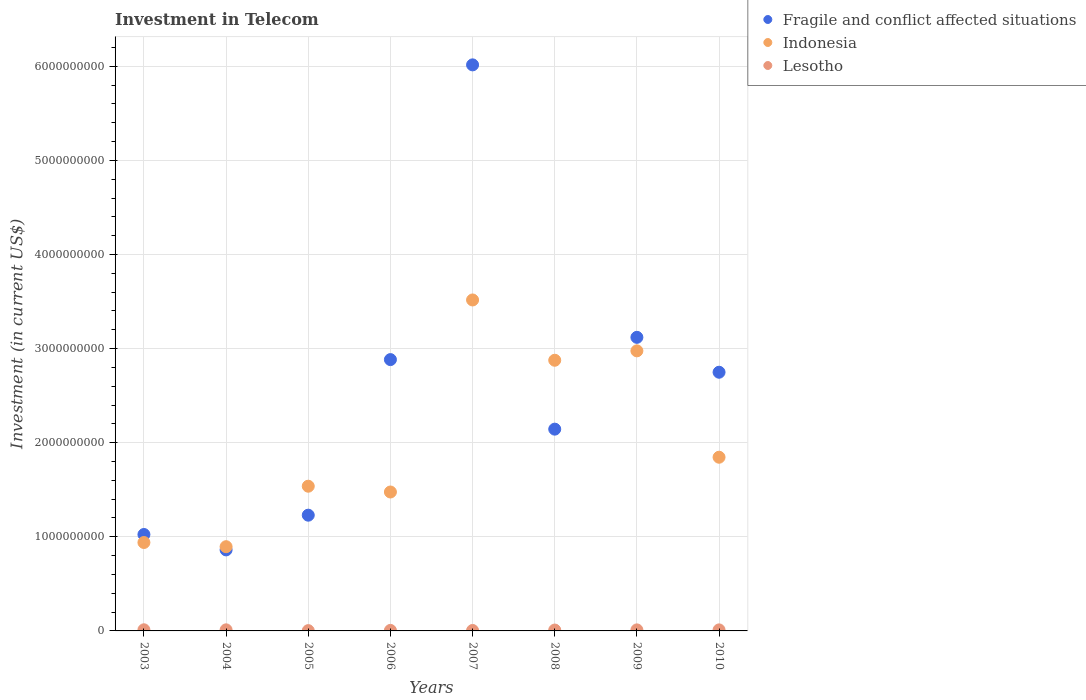What is the amount invested in telecom in Indonesia in 2008?
Provide a short and direct response. 2.88e+09. Across all years, what is the minimum amount invested in telecom in Fragile and conflict affected situations?
Provide a short and direct response. 8.61e+08. In which year was the amount invested in telecom in Indonesia maximum?
Keep it short and to the point. 2007. What is the total amount invested in telecom in Fragile and conflict affected situations in the graph?
Your answer should be very brief. 2.00e+1. What is the difference between the amount invested in telecom in Fragile and conflict affected situations in 2004 and that in 2005?
Make the answer very short. -3.69e+08. What is the difference between the amount invested in telecom in Lesotho in 2009 and the amount invested in telecom in Fragile and conflict affected situations in 2010?
Offer a terse response. -2.74e+09. What is the average amount invested in telecom in Lesotho per year?
Your response must be concise. 8.52e+06. In the year 2005, what is the difference between the amount invested in telecom in Lesotho and amount invested in telecom in Indonesia?
Make the answer very short. -1.53e+09. In how many years, is the amount invested in telecom in Indonesia greater than 5400000000 US$?
Keep it short and to the point. 0. What is the ratio of the amount invested in telecom in Fragile and conflict affected situations in 2003 to that in 2008?
Your answer should be very brief. 0.48. Is the difference between the amount invested in telecom in Lesotho in 2006 and 2010 greater than the difference between the amount invested in telecom in Indonesia in 2006 and 2010?
Ensure brevity in your answer.  Yes. What is the difference between the highest and the lowest amount invested in telecom in Indonesia?
Keep it short and to the point. 2.62e+09. In how many years, is the amount invested in telecom in Lesotho greater than the average amount invested in telecom in Lesotho taken over all years?
Offer a very short reply. 5. Is the amount invested in telecom in Lesotho strictly greater than the amount invested in telecom in Fragile and conflict affected situations over the years?
Make the answer very short. No. How many dotlines are there?
Keep it short and to the point. 3. What is the difference between two consecutive major ticks on the Y-axis?
Your answer should be very brief. 1.00e+09. Are the values on the major ticks of Y-axis written in scientific E-notation?
Offer a terse response. No. Does the graph contain any zero values?
Keep it short and to the point. No. Does the graph contain grids?
Provide a short and direct response. Yes. Where does the legend appear in the graph?
Ensure brevity in your answer.  Top right. How are the legend labels stacked?
Ensure brevity in your answer.  Vertical. What is the title of the graph?
Your response must be concise. Investment in Telecom. What is the label or title of the X-axis?
Offer a terse response. Years. What is the label or title of the Y-axis?
Your answer should be very brief. Investment (in current US$). What is the Investment (in current US$) in Fragile and conflict affected situations in 2003?
Your answer should be very brief. 1.02e+09. What is the Investment (in current US$) in Indonesia in 2003?
Provide a succinct answer. 9.40e+08. What is the Investment (in current US$) in Fragile and conflict affected situations in 2004?
Provide a succinct answer. 8.61e+08. What is the Investment (in current US$) in Indonesia in 2004?
Your answer should be compact. 8.95e+08. What is the Investment (in current US$) of Lesotho in 2004?
Make the answer very short. 1.15e+07. What is the Investment (in current US$) in Fragile and conflict affected situations in 2005?
Offer a very short reply. 1.23e+09. What is the Investment (in current US$) of Indonesia in 2005?
Offer a terse response. 1.54e+09. What is the Investment (in current US$) in Lesotho in 2005?
Offer a very short reply. 3.00e+06. What is the Investment (in current US$) of Fragile and conflict affected situations in 2006?
Provide a succinct answer. 2.88e+09. What is the Investment (in current US$) of Indonesia in 2006?
Your answer should be compact. 1.48e+09. What is the Investment (in current US$) of Lesotho in 2006?
Provide a succinct answer. 5.53e+06. What is the Investment (in current US$) in Fragile and conflict affected situations in 2007?
Your answer should be compact. 6.01e+09. What is the Investment (in current US$) of Indonesia in 2007?
Your answer should be compact. 3.52e+09. What is the Investment (in current US$) in Lesotho in 2007?
Your answer should be very brief. 4.80e+06. What is the Investment (in current US$) in Fragile and conflict affected situations in 2008?
Provide a short and direct response. 2.14e+09. What is the Investment (in current US$) of Indonesia in 2008?
Keep it short and to the point. 2.88e+09. What is the Investment (in current US$) of Lesotho in 2008?
Provide a short and direct response. 9.30e+06. What is the Investment (in current US$) of Fragile and conflict affected situations in 2009?
Give a very brief answer. 3.12e+09. What is the Investment (in current US$) of Indonesia in 2009?
Provide a short and direct response. 2.98e+09. What is the Investment (in current US$) of Lesotho in 2009?
Provide a short and direct response. 1.10e+07. What is the Investment (in current US$) of Fragile and conflict affected situations in 2010?
Offer a very short reply. 2.75e+09. What is the Investment (in current US$) of Indonesia in 2010?
Your answer should be very brief. 1.85e+09. What is the Investment (in current US$) of Lesotho in 2010?
Ensure brevity in your answer.  1.10e+07. Across all years, what is the maximum Investment (in current US$) in Fragile and conflict affected situations?
Provide a succinct answer. 6.01e+09. Across all years, what is the maximum Investment (in current US$) in Indonesia?
Your answer should be very brief. 3.52e+09. Across all years, what is the minimum Investment (in current US$) of Fragile and conflict affected situations?
Provide a succinct answer. 8.61e+08. Across all years, what is the minimum Investment (in current US$) in Indonesia?
Offer a terse response. 8.95e+08. What is the total Investment (in current US$) in Fragile and conflict affected situations in the graph?
Your answer should be very brief. 2.00e+1. What is the total Investment (in current US$) in Indonesia in the graph?
Keep it short and to the point. 1.61e+1. What is the total Investment (in current US$) of Lesotho in the graph?
Keep it short and to the point. 6.81e+07. What is the difference between the Investment (in current US$) of Fragile and conflict affected situations in 2003 and that in 2004?
Make the answer very short. 1.64e+08. What is the difference between the Investment (in current US$) in Indonesia in 2003 and that in 2004?
Make the answer very short. 4.45e+07. What is the difference between the Investment (in current US$) in Fragile and conflict affected situations in 2003 and that in 2005?
Your response must be concise. -2.05e+08. What is the difference between the Investment (in current US$) in Indonesia in 2003 and that in 2005?
Your response must be concise. -5.98e+08. What is the difference between the Investment (in current US$) of Lesotho in 2003 and that in 2005?
Keep it short and to the point. 9.00e+06. What is the difference between the Investment (in current US$) in Fragile and conflict affected situations in 2003 and that in 2006?
Provide a succinct answer. -1.86e+09. What is the difference between the Investment (in current US$) in Indonesia in 2003 and that in 2006?
Your response must be concise. -5.37e+08. What is the difference between the Investment (in current US$) of Lesotho in 2003 and that in 2006?
Your response must be concise. 6.47e+06. What is the difference between the Investment (in current US$) in Fragile and conflict affected situations in 2003 and that in 2007?
Give a very brief answer. -4.99e+09. What is the difference between the Investment (in current US$) in Indonesia in 2003 and that in 2007?
Your answer should be compact. -2.58e+09. What is the difference between the Investment (in current US$) in Lesotho in 2003 and that in 2007?
Offer a terse response. 7.20e+06. What is the difference between the Investment (in current US$) of Fragile and conflict affected situations in 2003 and that in 2008?
Ensure brevity in your answer.  -1.12e+09. What is the difference between the Investment (in current US$) in Indonesia in 2003 and that in 2008?
Your answer should be very brief. -1.94e+09. What is the difference between the Investment (in current US$) in Lesotho in 2003 and that in 2008?
Provide a short and direct response. 2.70e+06. What is the difference between the Investment (in current US$) of Fragile and conflict affected situations in 2003 and that in 2009?
Your response must be concise. -2.09e+09. What is the difference between the Investment (in current US$) of Indonesia in 2003 and that in 2009?
Offer a very short reply. -2.04e+09. What is the difference between the Investment (in current US$) of Lesotho in 2003 and that in 2009?
Your response must be concise. 1.00e+06. What is the difference between the Investment (in current US$) of Fragile and conflict affected situations in 2003 and that in 2010?
Your answer should be very brief. -1.72e+09. What is the difference between the Investment (in current US$) of Indonesia in 2003 and that in 2010?
Make the answer very short. -9.06e+08. What is the difference between the Investment (in current US$) in Lesotho in 2003 and that in 2010?
Offer a very short reply. 1.00e+06. What is the difference between the Investment (in current US$) in Fragile and conflict affected situations in 2004 and that in 2005?
Provide a succinct answer. -3.69e+08. What is the difference between the Investment (in current US$) of Indonesia in 2004 and that in 2005?
Make the answer very short. -6.43e+08. What is the difference between the Investment (in current US$) in Lesotho in 2004 and that in 2005?
Provide a succinct answer. 8.50e+06. What is the difference between the Investment (in current US$) of Fragile and conflict affected situations in 2004 and that in 2006?
Provide a short and direct response. -2.02e+09. What is the difference between the Investment (in current US$) in Indonesia in 2004 and that in 2006?
Provide a succinct answer. -5.81e+08. What is the difference between the Investment (in current US$) in Lesotho in 2004 and that in 2006?
Ensure brevity in your answer.  5.97e+06. What is the difference between the Investment (in current US$) of Fragile and conflict affected situations in 2004 and that in 2007?
Provide a short and direct response. -5.15e+09. What is the difference between the Investment (in current US$) of Indonesia in 2004 and that in 2007?
Your response must be concise. -2.62e+09. What is the difference between the Investment (in current US$) of Lesotho in 2004 and that in 2007?
Keep it short and to the point. 6.70e+06. What is the difference between the Investment (in current US$) of Fragile and conflict affected situations in 2004 and that in 2008?
Your answer should be compact. -1.28e+09. What is the difference between the Investment (in current US$) of Indonesia in 2004 and that in 2008?
Your response must be concise. -1.98e+09. What is the difference between the Investment (in current US$) in Lesotho in 2004 and that in 2008?
Keep it short and to the point. 2.20e+06. What is the difference between the Investment (in current US$) in Fragile and conflict affected situations in 2004 and that in 2009?
Ensure brevity in your answer.  -2.26e+09. What is the difference between the Investment (in current US$) in Indonesia in 2004 and that in 2009?
Keep it short and to the point. -2.08e+09. What is the difference between the Investment (in current US$) in Lesotho in 2004 and that in 2009?
Give a very brief answer. 5.00e+05. What is the difference between the Investment (in current US$) of Fragile and conflict affected situations in 2004 and that in 2010?
Provide a succinct answer. -1.89e+09. What is the difference between the Investment (in current US$) of Indonesia in 2004 and that in 2010?
Offer a terse response. -9.51e+08. What is the difference between the Investment (in current US$) of Fragile and conflict affected situations in 2005 and that in 2006?
Offer a very short reply. -1.65e+09. What is the difference between the Investment (in current US$) of Indonesia in 2005 and that in 2006?
Keep it short and to the point. 6.15e+07. What is the difference between the Investment (in current US$) in Lesotho in 2005 and that in 2006?
Your response must be concise. -2.53e+06. What is the difference between the Investment (in current US$) in Fragile and conflict affected situations in 2005 and that in 2007?
Your answer should be compact. -4.78e+09. What is the difference between the Investment (in current US$) in Indonesia in 2005 and that in 2007?
Your answer should be compact. -1.98e+09. What is the difference between the Investment (in current US$) of Lesotho in 2005 and that in 2007?
Provide a short and direct response. -1.80e+06. What is the difference between the Investment (in current US$) in Fragile and conflict affected situations in 2005 and that in 2008?
Make the answer very short. -9.14e+08. What is the difference between the Investment (in current US$) of Indonesia in 2005 and that in 2008?
Provide a short and direct response. -1.34e+09. What is the difference between the Investment (in current US$) of Lesotho in 2005 and that in 2008?
Give a very brief answer. -6.30e+06. What is the difference between the Investment (in current US$) of Fragile and conflict affected situations in 2005 and that in 2009?
Provide a short and direct response. -1.89e+09. What is the difference between the Investment (in current US$) in Indonesia in 2005 and that in 2009?
Offer a very short reply. -1.44e+09. What is the difference between the Investment (in current US$) in Lesotho in 2005 and that in 2009?
Offer a terse response. -8.00e+06. What is the difference between the Investment (in current US$) of Fragile and conflict affected situations in 2005 and that in 2010?
Provide a succinct answer. -1.52e+09. What is the difference between the Investment (in current US$) in Indonesia in 2005 and that in 2010?
Ensure brevity in your answer.  -3.08e+08. What is the difference between the Investment (in current US$) in Lesotho in 2005 and that in 2010?
Offer a terse response. -8.00e+06. What is the difference between the Investment (in current US$) in Fragile and conflict affected situations in 2006 and that in 2007?
Ensure brevity in your answer.  -3.13e+09. What is the difference between the Investment (in current US$) of Indonesia in 2006 and that in 2007?
Make the answer very short. -2.04e+09. What is the difference between the Investment (in current US$) in Lesotho in 2006 and that in 2007?
Provide a succinct answer. 7.30e+05. What is the difference between the Investment (in current US$) of Fragile and conflict affected situations in 2006 and that in 2008?
Ensure brevity in your answer.  7.39e+08. What is the difference between the Investment (in current US$) of Indonesia in 2006 and that in 2008?
Give a very brief answer. -1.40e+09. What is the difference between the Investment (in current US$) of Lesotho in 2006 and that in 2008?
Your answer should be compact. -3.77e+06. What is the difference between the Investment (in current US$) of Fragile and conflict affected situations in 2006 and that in 2009?
Provide a short and direct response. -2.37e+08. What is the difference between the Investment (in current US$) of Indonesia in 2006 and that in 2009?
Make the answer very short. -1.50e+09. What is the difference between the Investment (in current US$) of Lesotho in 2006 and that in 2009?
Make the answer very short. -5.47e+06. What is the difference between the Investment (in current US$) of Fragile and conflict affected situations in 2006 and that in 2010?
Your response must be concise. 1.34e+08. What is the difference between the Investment (in current US$) of Indonesia in 2006 and that in 2010?
Give a very brief answer. -3.70e+08. What is the difference between the Investment (in current US$) of Lesotho in 2006 and that in 2010?
Keep it short and to the point. -5.47e+06. What is the difference between the Investment (in current US$) in Fragile and conflict affected situations in 2007 and that in 2008?
Keep it short and to the point. 3.87e+09. What is the difference between the Investment (in current US$) of Indonesia in 2007 and that in 2008?
Keep it short and to the point. 6.41e+08. What is the difference between the Investment (in current US$) of Lesotho in 2007 and that in 2008?
Offer a terse response. -4.50e+06. What is the difference between the Investment (in current US$) in Fragile and conflict affected situations in 2007 and that in 2009?
Offer a very short reply. 2.90e+09. What is the difference between the Investment (in current US$) of Indonesia in 2007 and that in 2009?
Offer a terse response. 5.41e+08. What is the difference between the Investment (in current US$) of Lesotho in 2007 and that in 2009?
Offer a terse response. -6.20e+06. What is the difference between the Investment (in current US$) of Fragile and conflict affected situations in 2007 and that in 2010?
Your answer should be compact. 3.27e+09. What is the difference between the Investment (in current US$) of Indonesia in 2007 and that in 2010?
Give a very brief answer. 1.67e+09. What is the difference between the Investment (in current US$) in Lesotho in 2007 and that in 2010?
Offer a terse response. -6.20e+06. What is the difference between the Investment (in current US$) in Fragile and conflict affected situations in 2008 and that in 2009?
Your answer should be compact. -9.76e+08. What is the difference between the Investment (in current US$) in Indonesia in 2008 and that in 2009?
Your response must be concise. -9.99e+07. What is the difference between the Investment (in current US$) in Lesotho in 2008 and that in 2009?
Provide a short and direct response. -1.70e+06. What is the difference between the Investment (in current US$) in Fragile and conflict affected situations in 2008 and that in 2010?
Keep it short and to the point. -6.05e+08. What is the difference between the Investment (in current US$) in Indonesia in 2008 and that in 2010?
Provide a succinct answer. 1.03e+09. What is the difference between the Investment (in current US$) of Lesotho in 2008 and that in 2010?
Ensure brevity in your answer.  -1.70e+06. What is the difference between the Investment (in current US$) of Fragile and conflict affected situations in 2009 and that in 2010?
Provide a short and direct response. 3.71e+08. What is the difference between the Investment (in current US$) in Indonesia in 2009 and that in 2010?
Your answer should be very brief. 1.13e+09. What is the difference between the Investment (in current US$) in Lesotho in 2009 and that in 2010?
Your response must be concise. 0. What is the difference between the Investment (in current US$) in Fragile and conflict affected situations in 2003 and the Investment (in current US$) in Indonesia in 2004?
Make the answer very short. 1.30e+08. What is the difference between the Investment (in current US$) in Fragile and conflict affected situations in 2003 and the Investment (in current US$) in Lesotho in 2004?
Offer a very short reply. 1.01e+09. What is the difference between the Investment (in current US$) of Indonesia in 2003 and the Investment (in current US$) of Lesotho in 2004?
Give a very brief answer. 9.28e+08. What is the difference between the Investment (in current US$) of Fragile and conflict affected situations in 2003 and the Investment (in current US$) of Indonesia in 2005?
Offer a terse response. -5.13e+08. What is the difference between the Investment (in current US$) of Fragile and conflict affected situations in 2003 and the Investment (in current US$) of Lesotho in 2005?
Make the answer very short. 1.02e+09. What is the difference between the Investment (in current US$) in Indonesia in 2003 and the Investment (in current US$) in Lesotho in 2005?
Offer a terse response. 9.36e+08. What is the difference between the Investment (in current US$) of Fragile and conflict affected situations in 2003 and the Investment (in current US$) of Indonesia in 2006?
Provide a succinct answer. -4.52e+08. What is the difference between the Investment (in current US$) of Fragile and conflict affected situations in 2003 and the Investment (in current US$) of Lesotho in 2006?
Your answer should be very brief. 1.02e+09. What is the difference between the Investment (in current US$) of Indonesia in 2003 and the Investment (in current US$) of Lesotho in 2006?
Offer a terse response. 9.34e+08. What is the difference between the Investment (in current US$) of Fragile and conflict affected situations in 2003 and the Investment (in current US$) of Indonesia in 2007?
Provide a short and direct response. -2.49e+09. What is the difference between the Investment (in current US$) of Fragile and conflict affected situations in 2003 and the Investment (in current US$) of Lesotho in 2007?
Keep it short and to the point. 1.02e+09. What is the difference between the Investment (in current US$) in Indonesia in 2003 and the Investment (in current US$) in Lesotho in 2007?
Make the answer very short. 9.35e+08. What is the difference between the Investment (in current US$) of Fragile and conflict affected situations in 2003 and the Investment (in current US$) of Indonesia in 2008?
Your answer should be very brief. -1.85e+09. What is the difference between the Investment (in current US$) in Fragile and conflict affected situations in 2003 and the Investment (in current US$) in Lesotho in 2008?
Offer a terse response. 1.02e+09. What is the difference between the Investment (in current US$) of Indonesia in 2003 and the Investment (in current US$) of Lesotho in 2008?
Your answer should be compact. 9.30e+08. What is the difference between the Investment (in current US$) in Fragile and conflict affected situations in 2003 and the Investment (in current US$) in Indonesia in 2009?
Your answer should be very brief. -1.95e+09. What is the difference between the Investment (in current US$) of Fragile and conflict affected situations in 2003 and the Investment (in current US$) of Lesotho in 2009?
Give a very brief answer. 1.01e+09. What is the difference between the Investment (in current US$) in Indonesia in 2003 and the Investment (in current US$) in Lesotho in 2009?
Offer a terse response. 9.28e+08. What is the difference between the Investment (in current US$) in Fragile and conflict affected situations in 2003 and the Investment (in current US$) in Indonesia in 2010?
Keep it short and to the point. -8.21e+08. What is the difference between the Investment (in current US$) of Fragile and conflict affected situations in 2003 and the Investment (in current US$) of Lesotho in 2010?
Your answer should be compact. 1.01e+09. What is the difference between the Investment (in current US$) of Indonesia in 2003 and the Investment (in current US$) of Lesotho in 2010?
Provide a succinct answer. 9.28e+08. What is the difference between the Investment (in current US$) of Fragile and conflict affected situations in 2004 and the Investment (in current US$) of Indonesia in 2005?
Give a very brief answer. -6.77e+08. What is the difference between the Investment (in current US$) of Fragile and conflict affected situations in 2004 and the Investment (in current US$) of Lesotho in 2005?
Give a very brief answer. 8.58e+08. What is the difference between the Investment (in current US$) in Indonesia in 2004 and the Investment (in current US$) in Lesotho in 2005?
Your answer should be very brief. 8.92e+08. What is the difference between the Investment (in current US$) in Fragile and conflict affected situations in 2004 and the Investment (in current US$) in Indonesia in 2006?
Provide a succinct answer. -6.15e+08. What is the difference between the Investment (in current US$) of Fragile and conflict affected situations in 2004 and the Investment (in current US$) of Lesotho in 2006?
Keep it short and to the point. 8.55e+08. What is the difference between the Investment (in current US$) in Indonesia in 2004 and the Investment (in current US$) in Lesotho in 2006?
Provide a succinct answer. 8.89e+08. What is the difference between the Investment (in current US$) of Fragile and conflict affected situations in 2004 and the Investment (in current US$) of Indonesia in 2007?
Give a very brief answer. -2.66e+09. What is the difference between the Investment (in current US$) in Fragile and conflict affected situations in 2004 and the Investment (in current US$) in Lesotho in 2007?
Your answer should be very brief. 8.56e+08. What is the difference between the Investment (in current US$) of Indonesia in 2004 and the Investment (in current US$) of Lesotho in 2007?
Ensure brevity in your answer.  8.90e+08. What is the difference between the Investment (in current US$) in Fragile and conflict affected situations in 2004 and the Investment (in current US$) in Indonesia in 2008?
Ensure brevity in your answer.  -2.02e+09. What is the difference between the Investment (in current US$) in Fragile and conflict affected situations in 2004 and the Investment (in current US$) in Lesotho in 2008?
Make the answer very short. 8.52e+08. What is the difference between the Investment (in current US$) of Indonesia in 2004 and the Investment (in current US$) of Lesotho in 2008?
Offer a very short reply. 8.86e+08. What is the difference between the Investment (in current US$) in Fragile and conflict affected situations in 2004 and the Investment (in current US$) in Indonesia in 2009?
Your answer should be very brief. -2.12e+09. What is the difference between the Investment (in current US$) of Fragile and conflict affected situations in 2004 and the Investment (in current US$) of Lesotho in 2009?
Your answer should be compact. 8.50e+08. What is the difference between the Investment (in current US$) of Indonesia in 2004 and the Investment (in current US$) of Lesotho in 2009?
Give a very brief answer. 8.84e+08. What is the difference between the Investment (in current US$) of Fragile and conflict affected situations in 2004 and the Investment (in current US$) of Indonesia in 2010?
Your response must be concise. -9.85e+08. What is the difference between the Investment (in current US$) in Fragile and conflict affected situations in 2004 and the Investment (in current US$) in Lesotho in 2010?
Make the answer very short. 8.50e+08. What is the difference between the Investment (in current US$) in Indonesia in 2004 and the Investment (in current US$) in Lesotho in 2010?
Provide a succinct answer. 8.84e+08. What is the difference between the Investment (in current US$) of Fragile and conflict affected situations in 2005 and the Investment (in current US$) of Indonesia in 2006?
Provide a short and direct response. -2.46e+08. What is the difference between the Investment (in current US$) of Fragile and conflict affected situations in 2005 and the Investment (in current US$) of Lesotho in 2006?
Provide a short and direct response. 1.22e+09. What is the difference between the Investment (in current US$) in Indonesia in 2005 and the Investment (in current US$) in Lesotho in 2006?
Your response must be concise. 1.53e+09. What is the difference between the Investment (in current US$) in Fragile and conflict affected situations in 2005 and the Investment (in current US$) in Indonesia in 2007?
Ensure brevity in your answer.  -2.29e+09. What is the difference between the Investment (in current US$) in Fragile and conflict affected situations in 2005 and the Investment (in current US$) in Lesotho in 2007?
Keep it short and to the point. 1.22e+09. What is the difference between the Investment (in current US$) in Indonesia in 2005 and the Investment (in current US$) in Lesotho in 2007?
Offer a terse response. 1.53e+09. What is the difference between the Investment (in current US$) of Fragile and conflict affected situations in 2005 and the Investment (in current US$) of Indonesia in 2008?
Your answer should be compact. -1.65e+09. What is the difference between the Investment (in current US$) of Fragile and conflict affected situations in 2005 and the Investment (in current US$) of Lesotho in 2008?
Your answer should be very brief. 1.22e+09. What is the difference between the Investment (in current US$) in Indonesia in 2005 and the Investment (in current US$) in Lesotho in 2008?
Give a very brief answer. 1.53e+09. What is the difference between the Investment (in current US$) in Fragile and conflict affected situations in 2005 and the Investment (in current US$) in Indonesia in 2009?
Your answer should be compact. -1.75e+09. What is the difference between the Investment (in current US$) of Fragile and conflict affected situations in 2005 and the Investment (in current US$) of Lesotho in 2009?
Your answer should be compact. 1.22e+09. What is the difference between the Investment (in current US$) in Indonesia in 2005 and the Investment (in current US$) in Lesotho in 2009?
Your answer should be very brief. 1.53e+09. What is the difference between the Investment (in current US$) of Fragile and conflict affected situations in 2005 and the Investment (in current US$) of Indonesia in 2010?
Your answer should be very brief. -6.16e+08. What is the difference between the Investment (in current US$) of Fragile and conflict affected situations in 2005 and the Investment (in current US$) of Lesotho in 2010?
Make the answer very short. 1.22e+09. What is the difference between the Investment (in current US$) in Indonesia in 2005 and the Investment (in current US$) in Lesotho in 2010?
Keep it short and to the point. 1.53e+09. What is the difference between the Investment (in current US$) of Fragile and conflict affected situations in 2006 and the Investment (in current US$) of Indonesia in 2007?
Ensure brevity in your answer.  -6.34e+08. What is the difference between the Investment (in current US$) of Fragile and conflict affected situations in 2006 and the Investment (in current US$) of Lesotho in 2007?
Keep it short and to the point. 2.88e+09. What is the difference between the Investment (in current US$) of Indonesia in 2006 and the Investment (in current US$) of Lesotho in 2007?
Make the answer very short. 1.47e+09. What is the difference between the Investment (in current US$) of Fragile and conflict affected situations in 2006 and the Investment (in current US$) of Indonesia in 2008?
Ensure brevity in your answer.  6.93e+06. What is the difference between the Investment (in current US$) in Fragile and conflict affected situations in 2006 and the Investment (in current US$) in Lesotho in 2008?
Your response must be concise. 2.87e+09. What is the difference between the Investment (in current US$) of Indonesia in 2006 and the Investment (in current US$) of Lesotho in 2008?
Make the answer very short. 1.47e+09. What is the difference between the Investment (in current US$) in Fragile and conflict affected situations in 2006 and the Investment (in current US$) in Indonesia in 2009?
Your answer should be compact. -9.30e+07. What is the difference between the Investment (in current US$) of Fragile and conflict affected situations in 2006 and the Investment (in current US$) of Lesotho in 2009?
Provide a short and direct response. 2.87e+09. What is the difference between the Investment (in current US$) of Indonesia in 2006 and the Investment (in current US$) of Lesotho in 2009?
Offer a very short reply. 1.47e+09. What is the difference between the Investment (in current US$) in Fragile and conflict affected situations in 2006 and the Investment (in current US$) in Indonesia in 2010?
Offer a very short reply. 1.04e+09. What is the difference between the Investment (in current US$) in Fragile and conflict affected situations in 2006 and the Investment (in current US$) in Lesotho in 2010?
Make the answer very short. 2.87e+09. What is the difference between the Investment (in current US$) of Indonesia in 2006 and the Investment (in current US$) of Lesotho in 2010?
Offer a terse response. 1.47e+09. What is the difference between the Investment (in current US$) in Fragile and conflict affected situations in 2007 and the Investment (in current US$) in Indonesia in 2008?
Provide a succinct answer. 3.14e+09. What is the difference between the Investment (in current US$) of Fragile and conflict affected situations in 2007 and the Investment (in current US$) of Lesotho in 2008?
Your response must be concise. 6.01e+09. What is the difference between the Investment (in current US$) of Indonesia in 2007 and the Investment (in current US$) of Lesotho in 2008?
Keep it short and to the point. 3.51e+09. What is the difference between the Investment (in current US$) in Fragile and conflict affected situations in 2007 and the Investment (in current US$) in Indonesia in 2009?
Give a very brief answer. 3.04e+09. What is the difference between the Investment (in current US$) in Fragile and conflict affected situations in 2007 and the Investment (in current US$) in Lesotho in 2009?
Provide a short and direct response. 6.00e+09. What is the difference between the Investment (in current US$) in Indonesia in 2007 and the Investment (in current US$) in Lesotho in 2009?
Keep it short and to the point. 3.51e+09. What is the difference between the Investment (in current US$) of Fragile and conflict affected situations in 2007 and the Investment (in current US$) of Indonesia in 2010?
Your answer should be compact. 4.17e+09. What is the difference between the Investment (in current US$) of Fragile and conflict affected situations in 2007 and the Investment (in current US$) of Lesotho in 2010?
Keep it short and to the point. 6.00e+09. What is the difference between the Investment (in current US$) in Indonesia in 2007 and the Investment (in current US$) in Lesotho in 2010?
Offer a terse response. 3.51e+09. What is the difference between the Investment (in current US$) of Fragile and conflict affected situations in 2008 and the Investment (in current US$) of Indonesia in 2009?
Offer a terse response. -8.32e+08. What is the difference between the Investment (in current US$) of Fragile and conflict affected situations in 2008 and the Investment (in current US$) of Lesotho in 2009?
Make the answer very short. 2.13e+09. What is the difference between the Investment (in current US$) in Indonesia in 2008 and the Investment (in current US$) in Lesotho in 2009?
Offer a terse response. 2.86e+09. What is the difference between the Investment (in current US$) of Fragile and conflict affected situations in 2008 and the Investment (in current US$) of Indonesia in 2010?
Provide a short and direct response. 2.98e+08. What is the difference between the Investment (in current US$) of Fragile and conflict affected situations in 2008 and the Investment (in current US$) of Lesotho in 2010?
Give a very brief answer. 2.13e+09. What is the difference between the Investment (in current US$) of Indonesia in 2008 and the Investment (in current US$) of Lesotho in 2010?
Make the answer very short. 2.86e+09. What is the difference between the Investment (in current US$) of Fragile and conflict affected situations in 2009 and the Investment (in current US$) of Indonesia in 2010?
Your answer should be compact. 1.27e+09. What is the difference between the Investment (in current US$) of Fragile and conflict affected situations in 2009 and the Investment (in current US$) of Lesotho in 2010?
Offer a terse response. 3.11e+09. What is the difference between the Investment (in current US$) in Indonesia in 2009 and the Investment (in current US$) in Lesotho in 2010?
Keep it short and to the point. 2.96e+09. What is the average Investment (in current US$) in Fragile and conflict affected situations per year?
Your response must be concise. 2.50e+09. What is the average Investment (in current US$) in Indonesia per year?
Offer a terse response. 2.01e+09. What is the average Investment (in current US$) of Lesotho per year?
Keep it short and to the point. 8.52e+06. In the year 2003, what is the difference between the Investment (in current US$) of Fragile and conflict affected situations and Investment (in current US$) of Indonesia?
Offer a very short reply. 8.50e+07. In the year 2003, what is the difference between the Investment (in current US$) in Fragile and conflict affected situations and Investment (in current US$) in Lesotho?
Offer a terse response. 1.01e+09. In the year 2003, what is the difference between the Investment (in current US$) in Indonesia and Investment (in current US$) in Lesotho?
Your response must be concise. 9.28e+08. In the year 2004, what is the difference between the Investment (in current US$) in Fragile and conflict affected situations and Investment (in current US$) in Indonesia?
Your answer should be very brief. -3.42e+07. In the year 2004, what is the difference between the Investment (in current US$) in Fragile and conflict affected situations and Investment (in current US$) in Lesotho?
Provide a short and direct response. 8.49e+08. In the year 2004, what is the difference between the Investment (in current US$) in Indonesia and Investment (in current US$) in Lesotho?
Offer a terse response. 8.84e+08. In the year 2005, what is the difference between the Investment (in current US$) in Fragile and conflict affected situations and Investment (in current US$) in Indonesia?
Keep it short and to the point. -3.08e+08. In the year 2005, what is the difference between the Investment (in current US$) in Fragile and conflict affected situations and Investment (in current US$) in Lesotho?
Offer a terse response. 1.23e+09. In the year 2005, what is the difference between the Investment (in current US$) in Indonesia and Investment (in current US$) in Lesotho?
Your response must be concise. 1.53e+09. In the year 2006, what is the difference between the Investment (in current US$) in Fragile and conflict affected situations and Investment (in current US$) in Indonesia?
Give a very brief answer. 1.41e+09. In the year 2006, what is the difference between the Investment (in current US$) in Fragile and conflict affected situations and Investment (in current US$) in Lesotho?
Your answer should be compact. 2.88e+09. In the year 2006, what is the difference between the Investment (in current US$) in Indonesia and Investment (in current US$) in Lesotho?
Your answer should be very brief. 1.47e+09. In the year 2007, what is the difference between the Investment (in current US$) in Fragile and conflict affected situations and Investment (in current US$) in Indonesia?
Keep it short and to the point. 2.50e+09. In the year 2007, what is the difference between the Investment (in current US$) of Fragile and conflict affected situations and Investment (in current US$) of Lesotho?
Make the answer very short. 6.01e+09. In the year 2007, what is the difference between the Investment (in current US$) of Indonesia and Investment (in current US$) of Lesotho?
Your answer should be very brief. 3.51e+09. In the year 2008, what is the difference between the Investment (in current US$) in Fragile and conflict affected situations and Investment (in current US$) in Indonesia?
Give a very brief answer. -7.32e+08. In the year 2008, what is the difference between the Investment (in current US$) in Fragile and conflict affected situations and Investment (in current US$) in Lesotho?
Provide a succinct answer. 2.13e+09. In the year 2008, what is the difference between the Investment (in current US$) of Indonesia and Investment (in current US$) of Lesotho?
Your answer should be compact. 2.87e+09. In the year 2009, what is the difference between the Investment (in current US$) in Fragile and conflict affected situations and Investment (in current US$) in Indonesia?
Your response must be concise. 1.44e+08. In the year 2009, what is the difference between the Investment (in current US$) in Fragile and conflict affected situations and Investment (in current US$) in Lesotho?
Offer a terse response. 3.11e+09. In the year 2009, what is the difference between the Investment (in current US$) in Indonesia and Investment (in current US$) in Lesotho?
Give a very brief answer. 2.96e+09. In the year 2010, what is the difference between the Investment (in current US$) in Fragile and conflict affected situations and Investment (in current US$) in Indonesia?
Ensure brevity in your answer.  9.03e+08. In the year 2010, what is the difference between the Investment (in current US$) in Fragile and conflict affected situations and Investment (in current US$) in Lesotho?
Ensure brevity in your answer.  2.74e+09. In the year 2010, what is the difference between the Investment (in current US$) in Indonesia and Investment (in current US$) in Lesotho?
Provide a short and direct response. 1.83e+09. What is the ratio of the Investment (in current US$) in Fragile and conflict affected situations in 2003 to that in 2004?
Offer a terse response. 1.19. What is the ratio of the Investment (in current US$) in Indonesia in 2003 to that in 2004?
Give a very brief answer. 1.05. What is the ratio of the Investment (in current US$) of Lesotho in 2003 to that in 2004?
Keep it short and to the point. 1.04. What is the ratio of the Investment (in current US$) of Fragile and conflict affected situations in 2003 to that in 2005?
Provide a succinct answer. 0.83. What is the ratio of the Investment (in current US$) in Indonesia in 2003 to that in 2005?
Provide a short and direct response. 0.61. What is the ratio of the Investment (in current US$) of Fragile and conflict affected situations in 2003 to that in 2006?
Your answer should be very brief. 0.36. What is the ratio of the Investment (in current US$) of Indonesia in 2003 to that in 2006?
Keep it short and to the point. 0.64. What is the ratio of the Investment (in current US$) of Lesotho in 2003 to that in 2006?
Provide a short and direct response. 2.17. What is the ratio of the Investment (in current US$) of Fragile and conflict affected situations in 2003 to that in 2007?
Offer a terse response. 0.17. What is the ratio of the Investment (in current US$) in Indonesia in 2003 to that in 2007?
Offer a terse response. 0.27. What is the ratio of the Investment (in current US$) of Lesotho in 2003 to that in 2007?
Make the answer very short. 2.5. What is the ratio of the Investment (in current US$) in Fragile and conflict affected situations in 2003 to that in 2008?
Your answer should be very brief. 0.48. What is the ratio of the Investment (in current US$) of Indonesia in 2003 to that in 2008?
Offer a very short reply. 0.33. What is the ratio of the Investment (in current US$) of Lesotho in 2003 to that in 2008?
Offer a terse response. 1.29. What is the ratio of the Investment (in current US$) of Fragile and conflict affected situations in 2003 to that in 2009?
Keep it short and to the point. 0.33. What is the ratio of the Investment (in current US$) in Indonesia in 2003 to that in 2009?
Give a very brief answer. 0.32. What is the ratio of the Investment (in current US$) in Fragile and conflict affected situations in 2003 to that in 2010?
Your answer should be compact. 0.37. What is the ratio of the Investment (in current US$) of Indonesia in 2003 to that in 2010?
Provide a short and direct response. 0.51. What is the ratio of the Investment (in current US$) of Lesotho in 2003 to that in 2010?
Provide a succinct answer. 1.09. What is the ratio of the Investment (in current US$) in Fragile and conflict affected situations in 2004 to that in 2005?
Your response must be concise. 0.7. What is the ratio of the Investment (in current US$) of Indonesia in 2004 to that in 2005?
Ensure brevity in your answer.  0.58. What is the ratio of the Investment (in current US$) of Lesotho in 2004 to that in 2005?
Give a very brief answer. 3.83. What is the ratio of the Investment (in current US$) in Fragile and conflict affected situations in 2004 to that in 2006?
Your response must be concise. 0.3. What is the ratio of the Investment (in current US$) of Indonesia in 2004 to that in 2006?
Provide a succinct answer. 0.61. What is the ratio of the Investment (in current US$) in Lesotho in 2004 to that in 2006?
Your answer should be very brief. 2.08. What is the ratio of the Investment (in current US$) of Fragile and conflict affected situations in 2004 to that in 2007?
Provide a succinct answer. 0.14. What is the ratio of the Investment (in current US$) of Indonesia in 2004 to that in 2007?
Make the answer very short. 0.25. What is the ratio of the Investment (in current US$) in Lesotho in 2004 to that in 2007?
Give a very brief answer. 2.4. What is the ratio of the Investment (in current US$) in Fragile and conflict affected situations in 2004 to that in 2008?
Keep it short and to the point. 0.4. What is the ratio of the Investment (in current US$) in Indonesia in 2004 to that in 2008?
Keep it short and to the point. 0.31. What is the ratio of the Investment (in current US$) of Lesotho in 2004 to that in 2008?
Provide a short and direct response. 1.24. What is the ratio of the Investment (in current US$) of Fragile and conflict affected situations in 2004 to that in 2009?
Your answer should be very brief. 0.28. What is the ratio of the Investment (in current US$) of Indonesia in 2004 to that in 2009?
Offer a terse response. 0.3. What is the ratio of the Investment (in current US$) of Lesotho in 2004 to that in 2009?
Your answer should be very brief. 1.05. What is the ratio of the Investment (in current US$) of Fragile and conflict affected situations in 2004 to that in 2010?
Keep it short and to the point. 0.31. What is the ratio of the Investment (in current US$) of Indonesia in 2004 to that in 2010?
Provide a succinct answer. 0.48. What is the ratio of the Investment (in current US$) of Lesotho in 2004 to that in 2010?
Keep it short and to the point. 1.05. What is the ratio of the Investment (in current US$) of Fragile and conflict affected situations in 2005 to that in 2006?
Offer a very short reply. 0.43. What is the ratio of the Investment (in current US$) in Indonesia in 2005 to that in 2006?
Your response must be concise. 1.04. What is the ratio of the Investment (in current US$) in Lesotho in 2005 to that in 2006?
Give a very brief answer. 0.54. What is the ratio of the Investment (in current US$) in Fragile and conflict affected situations in 2005 to that in 2007?
Keep it short and to the point. 0.2. What is the ratio of the Investment (in current US$) of Indonesia in 2005 to that in 2007?
Give a very brief answer. 0.44. What is the ratio of the Investment (in current US$) of Lesotho in 2005 to that in 2007?
Offer a terse response. 0.62. What is the ratio of the Investment (in current US$) of Fragile and conflict affected situations in 2005 to that in 2008?
Offer a terse response. 0.57. What is the ratio of the Investment (in current US$) of Indonesia in 2005 to that in 2008?
Make the answer very short. 0.53. What is the ratio of the Investment (in current US$) in Lesotho in 2005 to that in 2008?
Offer a terse response. 0.32. What is the ratio of the Investment (in current US$) in Fragile and conflict affected situations in 2005 to that in 2009?
Your answer should be very brief. 0.39. What is the ratio of the Investment (in current US$) in Indonesia in 2005 to that in 2009?
Ensure brevity in your answer.  0.52. What is the ratio of the Investment (in current US$) in Lesotho in 2005 to that in 2009?
Give a very brief answer. 0.27. What is the ratio of the Investment (in current US$) of Fragile and conflict affected situations in 2005 to that in 2010?
Make the answer very short. 0.45. What is the ratio of the Investment (in current US$) in Indonesia in 2005 to that in 2010?
Provide a succinct answer. 0.83. What is the ratio of the Investment (in current US$) in Lesotho in 2005 to that in 2010?
Your answer should be very brief. 0.27. What is the ratio of the Investment (in current US$) of Fragile and conflict affected situations in 2006 to that in 2007?
Ensure brevity in your answer.  0.48. What is the ratio of the Investment (in current US$) of Indonesia in 2006 to that in 2007?
Provide a short and direct response. 0.42. What is the ratio of the Investment (in current US$) in Lesotho in 2006 to that in 2007?
Your answer should be very brief. 1.15. What is the ratio of the Investment (in current US$) of Fragile and conflict affected situations in 2006 to that in 2008?
Your answer should be very brief. 1.34. What is the ratio of the Investment (in current US$) in Indonesia in 2006 to that in 2008?
Your answer should be very brief. 0.51. What is the ratio of the Investment (in current US$) of Lesotho in 2006 to that in 2008?
Provide a succinct answer. 0.59. What is the ratio of the Investment (in current US$) in Fragile and conflict affected situations in 2006 to that in 2009?
Your answer should be very brief. 0.92. What is the ratio of the Investment (in current US$) of Indonesia in 2006 to that in 2009?
Offer a very short reply. 0.5. What is the ratio of the Investment (in current US$) of Lesotho in 2006 to that in 2009?
Keep it short and to the point. 0.5. What is the ratio of the Investment (in current US$) of Fragile and conflict affected situations in 2006 to that in 2010?
Offer a terse response. 1.05. What is the ratio of the Investment (in current US$) of Indonesia in 2006 to that in 2010?
Ensure brevity in your answer.  0.8. What is the ratio of the Investment (in current US$) in Lesotho in 2006 to that in 2010?
Make the answer very short. 0.5. What is the ratio of the Investment (in current US$) of Fragile and conflict affected situations in 2007 to that in 2008?
Offer a very short reply. 2.81. What is the ratio of the Investment (in current US$) of Indonesia in 2007 to that in 2008?
Your response must be concise. 1.22. What is the ratio of the Investment (in current US$) in Lesotho in 2007 to that in 2008?
Offer a terse response. 0.52. What is the ratio of the Investment (in current US$) in Fragile and conflict affected situations in 2007 to that in 2009?
Ensure brevity in your answer.  1.93. What is the ratio of the Investment (in current US$) in Indonesia in 2007 to that in 2009?
Ensure brevity in your answer.  1.18. What is the ratio of the Investment (in current US$) of Lesotho in 2007 to that in 2009?
Provide a short and direct response. 0.44. What is the ratio of the Investment (in current US$) in Fragile and conflict affected situations in 2007 to that in 2010?
Make the answer very short. 2.19. What is the ratio of the Investment (in current US$) of Indonesia in 2007 to that in 2010?
Your answer should be very brief. 1.91. What is the ratio of the Investment (in current US$) of Lesotho in 2007 to that in 2010?
Offer a terse response. 0.44. What is the ratio of the Investment (in current US$) of Fragile and conflict affected situations in 2008 to that in 2009?
Give a very brief answer. 0.69. What is the ratio of the Investment (in current US$) in Indonesia in 2008 to that in 2009?
Keep it short and to the point. 0.97. What is the ratio of the Investment (in current US$) of Lesotho in 2008 to that in 2009?
Offer a very short reply. 0.85. What is the ratio of the Investment (in current US$) of Fragile and conflict affected situations in 2008 to that in 2010?
Offer a very short reply. 0.78. What is the ratio of the Investment (in current US$) of Indonesia in 2008 to that in 2010?
Provide a short and direct response. 1.56. What is the ratio of the Investment (in current US$) in Lesotho in 2008 to that in 2010?
Offer a terse response. 0.85. What is the ratio of the Investment (in current US$) of Fragile and conflict affected situations in 2009 to that in 2010?
Your response must be concise. 1.13. What is the ratio of the Investment (in current US$) of Indonesia in 2009 to that in 2010?
Keep it short and to the point. 1.61. What is the difference between the highest and the second highest Investment (in current US$) of Fragile and conflict affected situations?
Provide a short and direct response. 2.90e+09. What is the difference between the highest and the second highest Investment (in current US$) in Indonesia?
Your answer should be very brief. 5.41e+08. What is the difference between the highest and the second highest Investment (in current US$) in Lesotho?
Your answer should be very brief. 5.00e+05. What is the difference between the highest and the lowest Investment (in current US$) in Fragile and conflict affected situations?
Offer a terse response. 5.15e+09. What is the difference between the highest and the lowest Investment (in current US$) of Indonesia?
Ensure brevity in your answer.  2.62e+09. What is the difference between the highest and the lowest Investment (in current US$) of Lesotho?
Ensure brevity in your answer.  9.00e+06. 